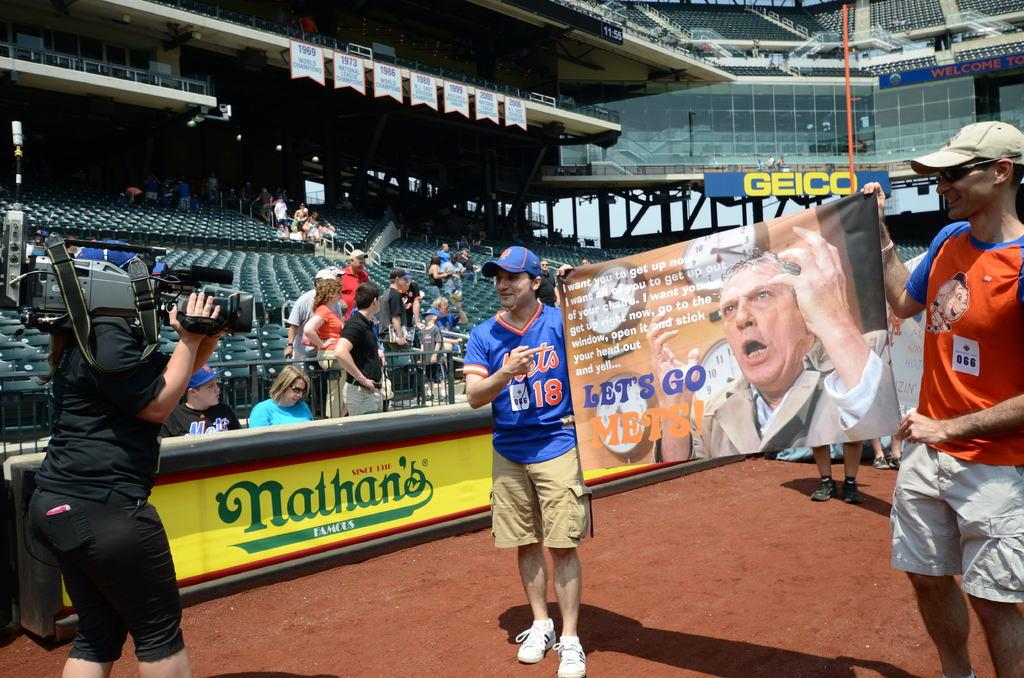Provide a one-sentence caption for the provided image. Two fans hold up a poster saying Lets go Mets. 